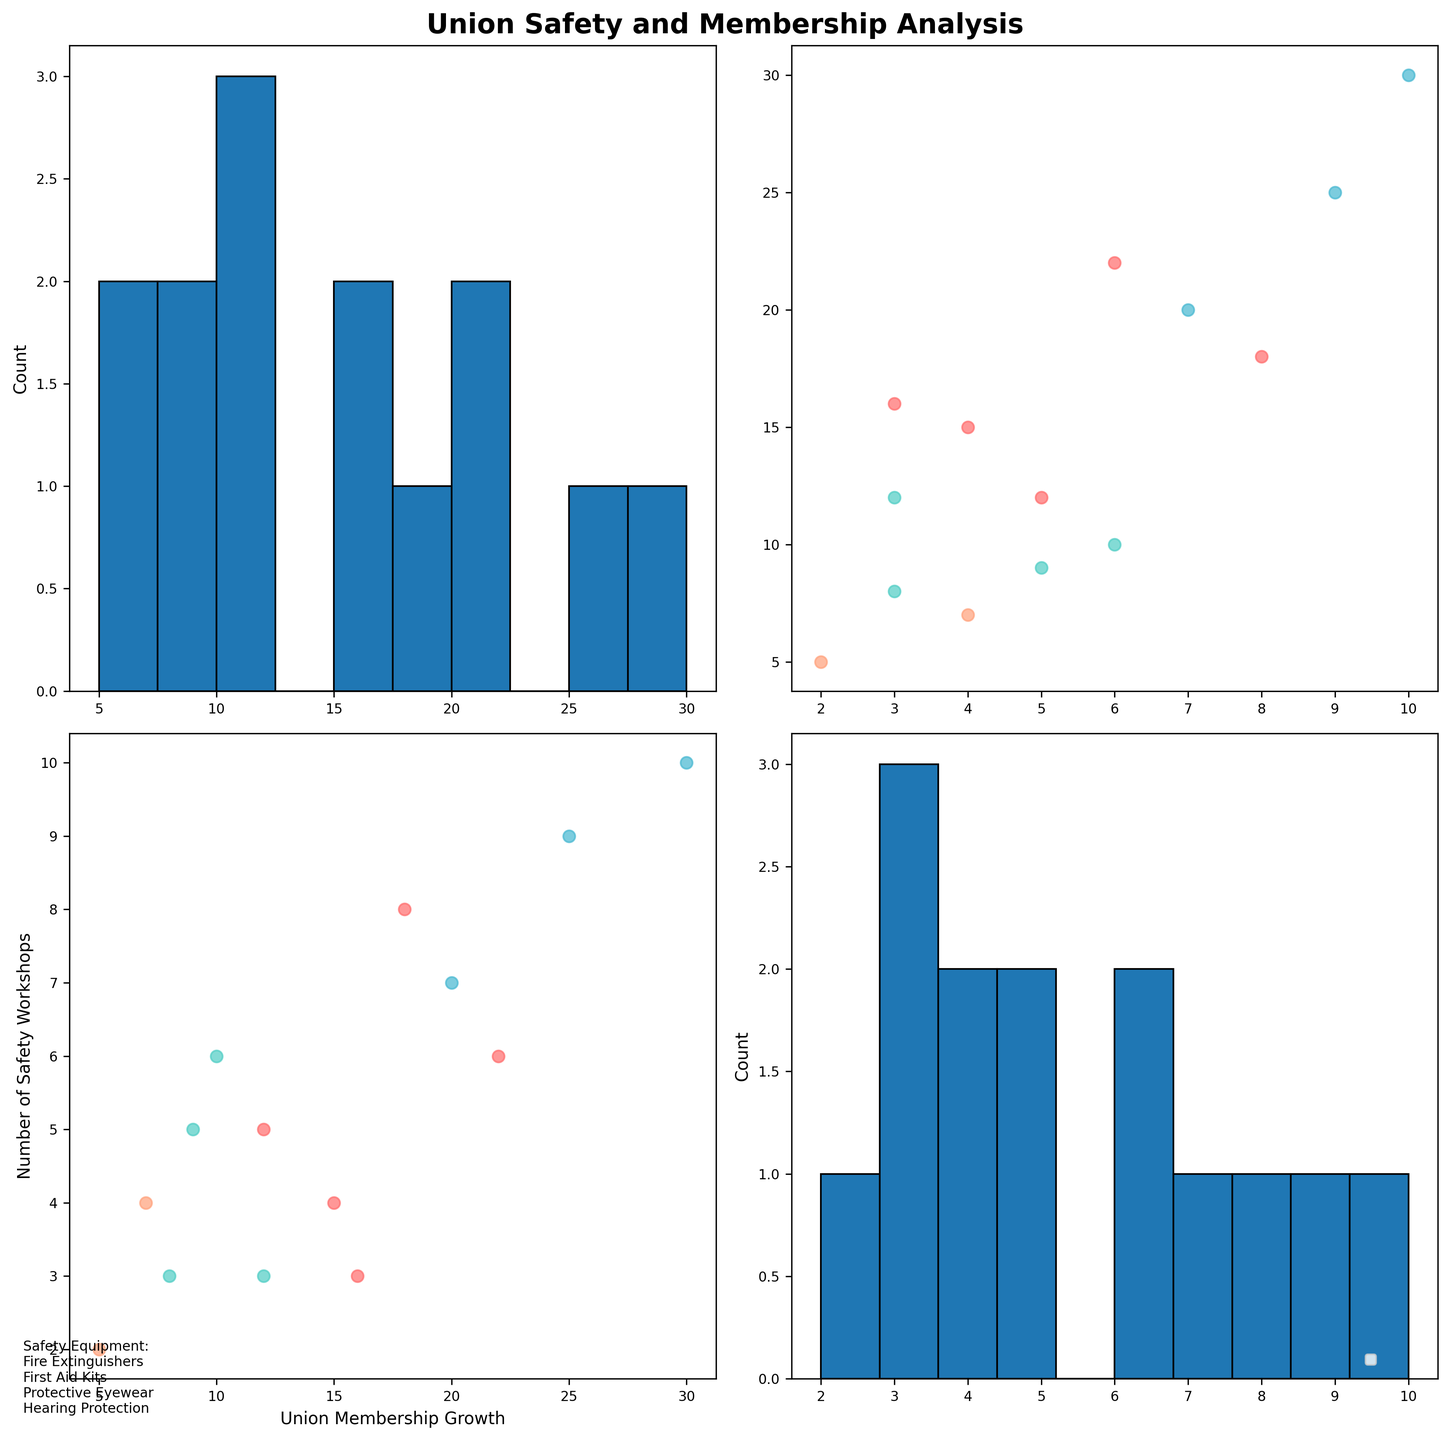What is the title of the figure? The title of the figure is displayed at the top center. It reads "Union Safety and Membership Analysis".
Answer: Union Safety and Membership Analysis Which department is represented by the red color? In the colors specified for departments, the red color represents the Warehouse department.
Answer: Warehouse How many types of safety equipment are listed in the figure? The equipment types are listed at the bottom left of the figure. They are Fire Extinguishers, First Aid Kits, Protective Eyewear, and Hearing Protection, amounting to four types.
Answer: 4 Which department had the highest number of safety workshops? By referring to the scatter plots, look at the department with the most clustered points towards the higher end of the 'Number of Safety Workshops' axis. The points for the Construction department are highest with up to 10 workshops.
Answer: Construction In which department is Protective Eyewear most commonly implemented? Look at the points labeled with different colors corresponding to departments and check the points associated with 'Protective Eyewear'. The scatter plots show most points associated with Protective Eyewear in the Construction department.
Answer: Construction What is the total count of Union Membership Growth values displayed? Look at the histograms along the diagonal that show the distribution of Union Membership Growth. Count each bin's heights to get the total number of data points. There should be a total of 14 values represented.
Answer: 14 How does the Union Membership Growth for Warehouse compare with Manufacturing? Compare the scatter points color-coded for Warehouse and Manufacturing under the 'Union Membership Growth' axis. You can notice that generally, the Warehouse points spread over a higher range of values than Manufacturing.
Answer: Warehouse has higher growth What's the average number of safety workshops conducted in the Manufacturing department? Identify the number of safety workshops (y-axis) for data points colored for Manufacturing department and compute the average. The points are (3, 6, 5, 3). The average is (3+6+5+3)/4 = 4.25.
Answer: 4.25 What is the relationship between the number of safety workshops and union membership growth? Analyze the scatter plots comparing 'Number of Safety Workshops' vs. 'Union Membership Growth'. There is a positive relationship where an increase in safety workshops generally corresponds with a higher union membership growth.
Answer: Positive relationship How many safety workshops were conducted when the union membership growth was 30? Look for the individual data point where the union membership growth is 30. The scatter plot shows this data point at 10 safety workshops.
Answer: 10 